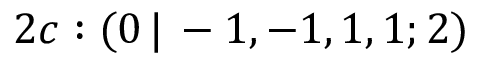<formula> <loc_0><loc_0><loc_500><loc_500>2 c \colon ( 0 \, | \, - 1 , - 1 , 1 , 1 ; 2 )</formula> 